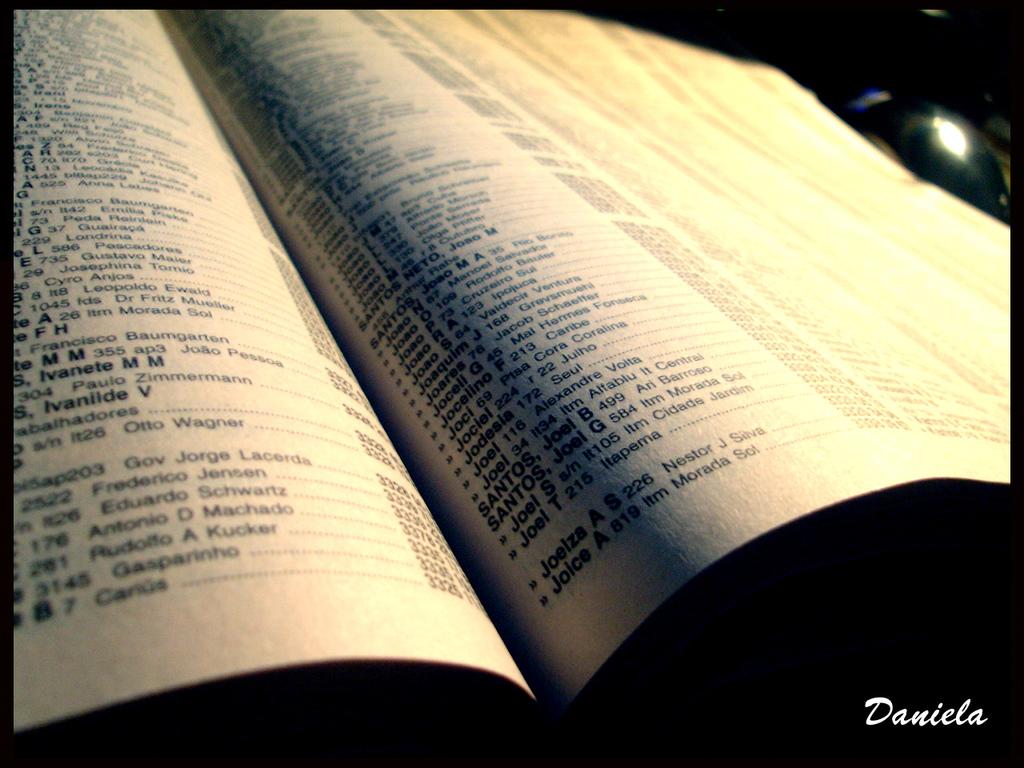What name is next to the 176 on the left page?
Give a very brief answer. Antonio d machado. 